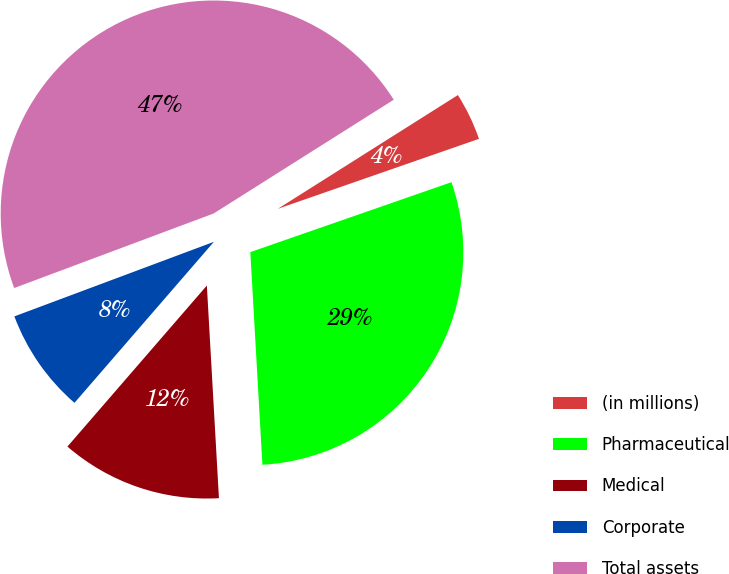Convert chart. <chart><loc_0><loc_0><loc_500><loc_500><pie_chart><fcel>(in millions)<fcel>Pharmaceutical<fcel>Medical<fcel>Corporate<fcel>Total assets<nl><fcel>3.64%<fcel>29.42%<fcel>12.26%<fcel>7.95%<fcel>46.72%<nl></chart> 